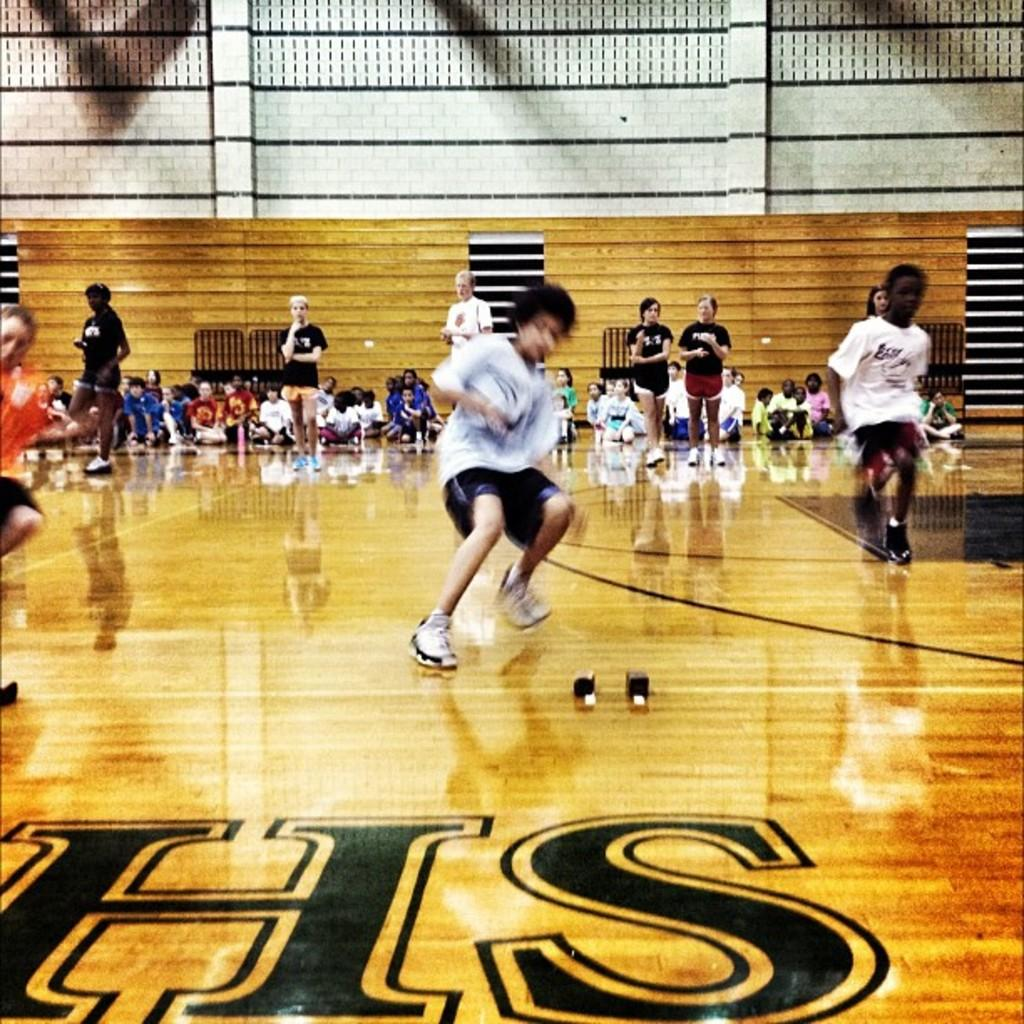What type of flooring is present in the image? There is a wooden floor in the image. What is happening on the wooden floor? There is a crowd of people on the wooden floor. What other wooden element is visible in the image? There is a wooden wall visible in the image. What can be seen on the bottom of the wooden floor? There is text visible on the bottom of the floor. What type of rifle is being used by the people in the image? There is no rifle present in the image; it features a crowd of people on a wooden floor with a wooden wall and text on the floor. What game are the people playing in the image? There is no game being played in the image; it simply shows a crowd of people on a wooden floor with a wooden wall and text on the floor. 